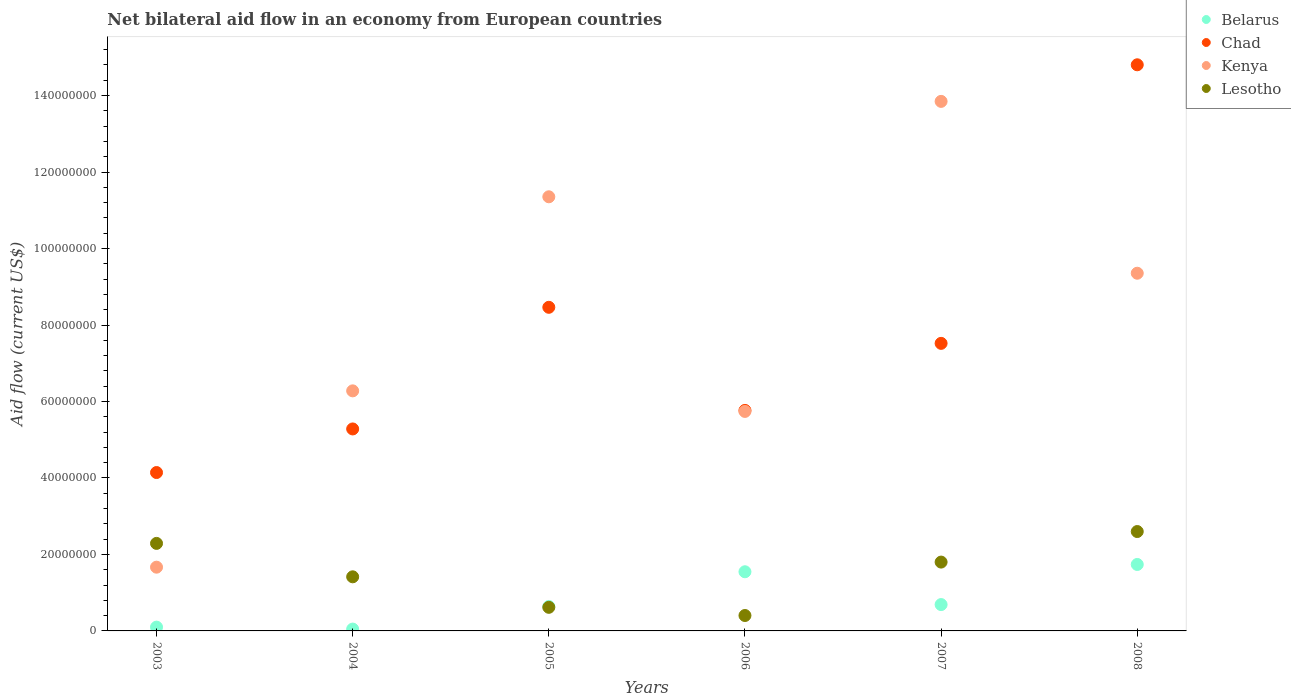What is the net bilateral aid flow in Belarus in 2006?
Provide a short and direct response. 1.55e+07. Across all years, what is the maximum net bilateral aid flow in Chad?
Your response must be concise. 1.48e+08. In which year was the net bilateral aid flow in Kenya maximum?
Provide a short and direct response. 2007. In which year was the net bilateral aid flow in Chad minimum?
Your answer should be very brief. 2003. What is the total net bilateral aid flow in Chad in the graph?
Ensure brevity in your answer.  4.60e+08. What is the difference between the net bilateral aid flow in Chad in 2007 and that in 2008?
Make the answer very short. -7.28e+07. What is the difference between the net bilateral aid flow in Kenya in 2004 and the net bilateral aid flow in Lesotho in 2008?
Keep it short and to the point. 3.68e+07. What is the average net bilateral aid flow in Chad per year?
Your answer should be compact. 7.66e+07. In the year 2005, what is the difference between the net bilateral aid flow in Lesotho and net bilateral aid flow in Belarus?
Your response must be concise. -2.20e+05. In how many years, is the net bilateral aid flow in Belarus greater than 124000000 US$?
Offer a terse response. 0. What is the ratio of the net bilateral aid flow in Kenya in 2005 to that in 2007?
Your answer should be compact. 0.82. Is the difference between the net bilateral aid flow in Lesotho in 2005 and 2007 greater than the difference between the net bilateral aid flow in Belarus in 2005 and 2007?
Offer a terse response. No. What is the difference between the highest and the second highest net bilateral aid flow in Chad?
Offer a very short reply. 6.34e+07. What is the difference between the highest and the lowest net bilateral aid flow in Kenya?
Your answer should be compact. 1.22e+08. Is it the case that in every year, the sum of the net bilateral aid flow in Lesotho and net bilateral aid flow in Belarus  is greater than the sum of net bilateral aid flow in Chad and net bilateral aid flow in Kenya?
Your response must be concise. No. Is it the case that in every year, the sum of the net bilateral aid flow in Lesotho and net bilateral aid flow in Belarus  is greater than the net bilateral aid flow in Kenya?
Keep it short and to the point. No. Does the net bilateral aid flow in Lesotho monotonically increase over the years?
Your answer should be very brief. No. Is the net bilateral aid flow in Chad strictly greater than the net bilateral aid flow in Lesotho over the years?
Provide a short and direct response. Yes. Does the graph contain any zero values?
Keep it short and to the point. No. Where does the legend appear in the graph?
Your answer should be very brief. Top right. What is the title of the graph?
Offer a very short reply. Net bilateral aid flow in an economy from European countries. Does "Seychelles" appear as one of the legend labels in the graph?
Your answer should be very brief. No. What is the Aid flow (current US$) of Belarus in 2003?
Ensure brevity in your answer.  9.90e+05. What is the Aid flow (current US$) in Chad in 2003?
Ensure brevity in your answer.  4.14e+07. What is the Aid flow (current US$) in Kenya in 2003?
Your response must be concise. 1.67e+07. What is the Aid flow (current US$) of Lesotho in 2003?
Ensure brevity in your answer.  2.29e+07. What is the Aid flow (current US$) of Belarus in 2004?
Your answer should be very brief. 4.80e+05. What is the Aid flow (current US$) of Chad in 2004?
Give a very brief answer. 5.28e+07. What is the Aid flow (current US$) of Kenya in 2004?
Offer a terse response. 6.28e+07. What is the Aid flow (current US$) in Lesotho in 2004?
Ensure brevity in your answer.  1.42e+07. What is the Aid flow (current US$) in Belarus in 2005?
Provide a succinct answer. 6.39e+06. What is the Aid flow (current US$) of Chad in 2005?
Offer a very short reply. 8.46e+07. What is the Aid flow (current US$) in Kenya in 2005?
Provide a succinct answer. 1.14e+08. What is the Aid flow (current US$) in Lesotho in 2005?
Offer a terse response. 6.17e+06. What is the Aid flow (current US$) in Belarus in 2006?
Provide a short and direct response. 1.55e+07. What is the Aid flow (current US$) in Chad in 2006?
Make the answer very short. 5.77e+07. What is the Aid flow (current US$) of Kenya in 2006?
Offer a terse response. 5.74e+07. What is the Aid flow (current US$) in Lesotho in 2006?
Your response must be concise. 4.03e+06. What is the Aid flow (current US$) of Belarus in 2007?
Provide a short and direct response. 6.89e+06. What is the Aid flow (current US$) in Chad in 2007?
Provide a succinct answer. 7.52e+07. What is the Aid flow (current US$) of Kenya in 2007?
Offer a terse response. 1.38e+08. What is the Aid flow (current US$) in Lesotho in 2007?
Your response must be concise. 1.80e+07. What is the Aid flow (current US$) in Belarus in 2008?
Give a very brief answer. 1.74e+07. What is the Aid flow (current US$) of Chad in 2008?
Provide a succinct answer. 1.48e+08. What is the Aid flow (current US$) in Kenya in 2008?
Ensure brevity in your answer.  9.35e+07. What is the Aid flow (current US$) in Lesotho in 2008?
Your answer should be very brief. 2.60e+07. Across all years, what is the maximum Aid flow (current US$) of Belarus?
Ensure brevity in your answer.  1.74e+07. Across all years, what is the maximum Aid flow (current US$) in Chad?
Make the answer very short. 1.48e+08. Across all years, what is the maximum Aid flow (current US$) of Kenya?
Your answer should be compact. 1.38e+08. Across all years, what is the maximum Aid flow (current US$) of Lesotho?
Ensure brevity in your answer.  2.60e+07. Across all years, what is the minimum Aid flow (current US$) of Belarus?
Make the answer very short. 4.80e+05. Across all years, what is the minimum Aid flow (current US$) of Chad?
Offer a very short reply. 4.14e+07. Across all years, what is the minimum Aid flow (current US$) in Kenya?
Provide a short and direct response. 1.67e+07. Across all years, what is the minimum Aid flow (current US$) of Lesotho?
Ensure brevity in your answer.  4.03e+06. What is the total Aid flow (current US$) of Belarus in the graph?
Your answer should be very brief. 4.76e+07. What is the total Aid flow (current US$) in Chad in the graph?
Your answer should be compact. 4.60e+08. What is the total Aid flow (current US$) of Kenya in the graph?
Keep it short and to the point. 4.82e+08. What is the total Aid flow (current US$) of Lesotho in the graph?
Provide a succinct answer. 9.12e+07. What is the difference between the Aid flow (current US$) in Belarus in 2003 and that in 2004?
Your answer should be very brief. 5.10e+05. What is the difference between the Aid flow (current US$) of Chad in 2003 and that in 2004?
Ensure brevity in your answer.  -1.14e+07. What is the difference between the Aid flow (current US$) in Kenya in 2003 and that in 2004?
Offer a very short reply. -4.61e+07. What is the difference between the Aid flow (current US$) of Lesotho in 2003 and that in 2004?
Keep it short and to the point. 8.74e+06. What is the difference between the Aid flow (current US$) in Belarus in 2003 and that in 2005?
Provide a succinct answer. -5.40e+06. What is the difference between the Aid flow (current US$) in Chad in 2003 and that in 2005?
Provide a succinct answer. -4.32e+07. What is the difference between the Aid flow (current US$) of Kenya in 2003 and that in 2005?
Make the answer very short. -9.69e+07. What is the difference between the Aid flow (current US$) in Lesotho in 2003 and that in 2005?
Ensure brevity in your answer.  1.67e+07. What is the difference between the Aid flow (current US$) of Belarus in 2003 and that in 2006?
Provide a short and direct response. -1.45e+07. What is the difference between the Aid flow (current US$) of Chad in 2003 and that in 2006?
Your response must be concise. -1.62e+07. What is the difference between the Aid flow (current US$) in Kenya in 2003 and that in 2006?
Offer a very short reply. -4.07e+07. What is the difference between the Aid flow (current US$) in Lesotho in 2003 and that in 2006?
Ensure brevity in your answer.  1.89e+07. What is the difference between the Aid flow (current US$) of Belarus in 2003 and that in 2007?
Your answer should be compact. -5.90e+06. What is the difference between the Aid flow (current US$) of Chad in 2003 and that in 2007?
Offer a terse response. -3.38e+07. What is the difference between the Aid flow (current US$) of Kenya in 2003 and that in 2007?
Provide a succinct answer. -1.22e+08. What is the difference between the Aid flow (current US$) of Lesotho in 2003 and that in 2007?
Your answer should be compact. 4.89e+06. What is the difference between the Aid flow (current US$) in Belarus in 2003 and that in 2008?
Ensure brevity in your answer.  -1.64e+07. What is the difference between the Aid flow (current US$) of Chad in 2003 and that in 2008?
Offer a very short reply. -1.07e+08. What is the difference between the Aid flow (current US$) in Kenya in 2003 and that in 2008?
Provide a succinct answer. -7.69e+07. What is the difference between the Aid flow (current US$) in Lesotho in 2003 and that in 2008?
Provide a succinct answer. -3.10e+06. What is the difference between the Aid flow (current US$) of Belarus in 2004 and that in 2005?
Your response must be concise. -5.91e+06. What is the difference between the Aid flow (current US$) in Chad in 2004 and that in 2005?
Your response must be concise. -3.18e+07. What is the difference between the Aid flow (current US$) in Kenya in 2004 and that in 2005?
Offer a terse response. -5.08e+07. What is the difference between the Aid flow (current US$) in Lesotho in 2004 and that in 2005?
Your response must be concise. 7.98e+06. What is the difference between the Aid flow (current US$) of Belarus in 2004 and that in 2006?
Your answer should be compact. -1.50e+07. What is the difference between the Aid flow (current US$) of Chad in 2004 and that in 2006?
Provide a short and direct response. -4.85e+06. What is the difference between the Aid flow (current US$) in Kenya in 2004 and that in 2006?
Give a very brief answer. 5.38e+06. What is the difference between the Aid flow (current US$) of Lesotho in 2004 and that in 2006?
Make the answer very short. 1.01e+07. What is the difference between the Aid flow (current US$) in Belarus in 2004 and that in 2007?
Make the answer very short. -6.41e+06. What is the difference between the Aid flow (current US$) in Chad in 2004 and that in 2007?
Provide a succinct answer. -2.24e+07. What is the difference between the Aid flow (current US$) of Kenya in 2004 and that in 2007?
Offer a terse response. -7.57e+07. What is the difference between the Aid flow (current US$) in Lesotho in 2004 and that in 2007?
Give a very brief answer. -3.85e+06. What is the difference between the Aid flow (current US$) of Belarus in 2004 and that in 2008?
Provide a short and direct response. -1.69e+07. What is the difference between the Aid flow (current US$) in Chad in 2004 and that in 2008?
Your answer should be compact. -9.52e+07. What is the difference between the Aid flow (current US$) in Kenya in 2004 and that in 2008?
Keep it short and to the point. -3.08e+07. What is the difference between the Aid flow (current US$) in Lesotho in 2004 and that in 2008?
Provide a succinct answer. -1.18e+07. What is the difference between the Aid flow (current US$) of Belarus in 2005 and that in 2006?
Offer a terse response. -9.08e+06. What is the difference between the Aid flow (current US$) in Chad in 2005 and that in 2006?
Provide a short and direct response. 2.70e+07. What is the difference between the Aid flow (current US$) of Kenya in 2005 and that in 2006?
Provide a succinct answer. 5.61e+07. What is the difference between the Aid flow (current US$) of Lesotho in 2005 and that in 2006?
Provide a short and direct response. 2.14e+06. What is the difference between the Aid flow (current US$) in Belarus in 2005 and that in 2007?
Your response must be concise. -5.00e+05. What is the difference between the Aid flow (current US$) in Chad in 2005 and that in 2007?
Keep it short and to the point. 9.43e+06. What is the difference between the Aid flow (current US$) of Kenya in 2005 and that in 2007?
Your answer should be compact. -2.50e+07. What is the difference between the Aid flow (current US$) in Lesotho in 2005 and that in 2007?
Offer a terse response. -1.18e+07. What is the difference between the Aid flow (current US$) in Belarus in 2005 and that in 2008?
Provide a short and direct response. -1.10e+07. What is the difference between the Aid flow (current US$) in Chad in 2005 and that in 2008?
Make the answer very short. -6.34e+07. What is the difference between the Aid flow (current US$) of Kenya in 2005 and that in 2008?
Offer a very short reply. 2.00e+07. What is the difference between the Aid flow (current US$) of Lesotho in 2005 and that in 2008?
Ensure brevity in your answer.  -1.98e+07. What is the difference between the Aid flow (current US$) of Belarus in 2006 and that in 2007?
Your response must be concise. 8.58e+06. What is the difference between the Aid flow (current US$) in Chad in 2006 and that in 2007?
Ensure brevity in your answer.  -1.75e+07. What is the difference between the Aid flow (current US$) in Kenya in 2006 and that in 2007?
Provide a succinct answer. -8.11e+07. What is the difference between the Aid flow (current US$) in Lesotho in 2006 and that in 2007?
Provide a short and direct response. -1.40e+07. What is the difference between the Aid flow (current US$) in Belarus in 2006 and that in 2008?
Offer a terse response. -1.91e+06. What is the difference between the Aid flow (current US$) of Chad in 2006 and that in 2008?
Your answer should be compact. -9.04e+07. What is the difference between the Aid flow (current US$) in Kenya in 2006 and that in 2008?
Make the answer very short. -3.61e+07. What is the difference between the Aid flow (current US$) of Lesotho in 2006 and that in 2008?
Make the answer very short. -2.20e+07. What is the difference between the Aid flow (current US$) in Belarus in 2007 and that in 2008?
Provide a succinct answer. -1.05e+07. What is the difference between the Aid flow (current US$) of Chad in 2007 and that in 2008?
Provide a succinct answer. -7.28e+07. What is the difference between the Aid flow (current US$) of Kenya in 2007 and that in 2008?
Make the answer very short. 4.49e+07. What is the difference between the Aid flow (current US$) in Lesotho in 2007 and that in 2008?
Your answer should be very brief. -7.99e+06. What is the difference between the Aid flow (current US$) of Belarus in 2003 and the Aid flow (current US$) of Chad in 2004?
Keep it short and to the point. -5.18e+07. What is the difference between the Aid flow (current US$) in Belarus in 2003 and the Aid flow (current US$) in Kenya in 2004?
Give a very brief answer. -6.18e+07. What is the difference between the Aid flow (current US$) of Belarus in 2003 and the Aid flow (current US$) of Lesotho in 2004?
Ensure brevity in your answer.  -1.32e+07. What is the difference between the Aid flow (current US$) of Chad in 2003 and the Aid flow (current US$) of Kenya in 2004?
Offer a terse response. -2.14e+07. What is the difference between the Aid flow (current US$) of Chad in 2003 and the Aid flow (current US$) of Lesotho in 2004?
Your answer should be compact. 2.73e+07. What is the difference between the Aid flow (current US$) of Kenya in 2003 and the Aid flow (current US$) of Lesotho in 2004?
Provide a short and direct response. 2.52e+06. What is the difference between the Aid flow (current US$) of Belarus in 2003 and the Aid flow (current US$) of Chad in 2005?
Offer a terse response. -8.36e+07. What is the difference between the Aid flow (current US$) in Belarus in 2003 and the Aid flow (current US$) in Kenya in 2005?
Your answer should be compact. -1.13e+08. What is the difference between the Aid flow (current US$) in Belarus in 2003 and the Aid flow (current US$) in Lesotho in 2005?
Offer a terse response. -5.18e+06. What is the difference between the Aid flow (current US$) of Chad in 2003 and the Aid flow (current US$) of Kenya in 2005?
Keep it short and to the point. -7.21e+07. What is the difference between the Aid flow (current US$) in Chad in 2003 and the Aid flow (current US$) in Lesotho in 2005?
Your answer should be compact. 3.52e+07. What is the difference between the Aid flow (current US$) of Kenya in 2003 and the Aid flow (current US$) of Lesotho in 2005?
Offer a terse response. 1.05e+07. What is the difference between the Aid flow (current US$) in Belarus in 2003 and the Aid flow (current US$) in Chad in 2006?
Keep it short and to the point. -5.67e+07. What is the difference between the Aid flow (current US$) of Belarus in 2003 and the Aid flow (current US$) of Kenya in 2006?
Give a very brief answer. -5.64e+07. What is the difference between the Aid flow (current US$) of Belarus in 2003 and the Aid flow (current US$) of Lesotho in 2006?
Make the answer very short. -3.04e+06. What is the difference between the Aid flow (current US$) of Chad in 2003 and the Aid flow (current US$) of Kenya in 2006?
Offer a very short reply. -1.60e+07. What is the difference between the Aid flow (current US$) in Chad in 2003 and the Aid flow (current US$) in Lesotho in 2006?
Give a very brief answer. 3.74e+07. What is the difference between the Aid flow (current US$) of Kenya in 2003 and the Aid flow (current US$) of Lesotho in 2006?
Keep it short and to the point. 1.26e+07. What is the difference between the Aid flow (current US$) of Belarus in 2003 and the Aid flow (current US$) of Chad in 2007?
Keep it short and to the point. -7.42e+07. What is the difference between the Aid flow (current US$) of Belarus in 2003 and the Aid flow (current US$) of Kenya in 2007?
Your response must be concise. -1.37e+08. What is the difference between the Aid flow (current US$) in Belarus in 2003 and the Aid flow (current US$) in Lesotho in 2007?
Your answer should be very brief. -1.70e+07. What is the difference between the Aid flow (current US$) of Chad in 2003 and the Aid flow (current US$) of Kenya in 2007?
Offer a terse response. -9.71e+07. What is the difference between the Aid flow (current US$) of Chad in 2003 and the Aid flow (current US$) of Lesotho in 2007?
Keep it short and to the point. 2.34e+07. What is the difference between the Aid flow (current US$) of Kenya in 2003 and the Aid flow (current US$) of Lesotho in 2007?
Make the answer very short. -1.33e+06. What is the difference between the Aid flow (current US$) in Belarus in 2003 and the Aid flow (current US$) in Chad in 2008?
Ensure brevity in your answer.  -1.47e+08. What is the difference between the Aid flow (current US$) of Belarus in 2003 and the Aid flow (current US$) of Kenya in 2008?
Provide a short and direct response. -9.26e+07. What is the difference between the Aid flow (current US$) in Belarus in 2003 and the Aid flow (current US$) in Lesotho in 2008?
Offer a very short reply. -2.50e+07. What is the difference between the Aid flow (current US$) in Chad in 2003 and the Aid flow (current US$) in Kenya in 2008?
Ensure brevity in your answer.  -5.21e+07. What is the difference between the Aid flow (current US$) of Chad in 2003 and the Aid flow (current US$) of Lesotho in 2008?
Offer a very short reply. 1.54e+07. What is the difference between the Aid flow (current US$) of Kenya in 2003 and the Aid flow (current US$) of Lesotho in 2008?
Your response must be concise. -9.32e+06. What is the difference between the Aid flow (current US$) of Belarus in 2004 and the Aid flow (current US$) of Chad in 2005?
Provide a short and direct response. -8.42e+07. What is the difference between the Aid flow (current US$) in Belarus in 2004 and the Aid flow (current US$) in Kenya in 2005?
Offer a very short reply. -1.13e+08. What is the difference between the Aid flow (current US$) in Belarus in 2004 and the Aid flow (current US$) in Lesotho in 2005?
Provide a short and direct response. -5.69e+06. What is the difference between the Aid flow (current US$) of Chad in 2004 and the Aid flow (current US$) of Kenya in 2005?
Keep it short and to the point. -6.07e+07. What is the difference between the Aid flow (current US$) in Chad in 2004 and the Aid flow (current US$) in Lesotho in 2005?
Give a very brief answer. 4.66e+07. What is the difference between the Aid flow (current US$) of Kenya in 2004 and the Aid flow (current US$) of Lesotho in 2005?
Give a very brief answer. 5.66e+07. What is the difference between the Aid flow (current US$) in Belarus in 2004 and the Aid flow (current US$) in Chad in 2006?
Make the answer very short. -5.72e+07. What is the difference between the Aid flow (current US$) of Belarus in 2004 and the Aid flow (current US$) of Kenya in 2006?
Provide a short and direct response. -5.69e+07. What is the difference between the Aid flow (current US$) of Belarus in 2004 and the Aid flow (current US$) of Lesotho in 2006?
Ensure brevity in your answer.  -3.55e+06. What is the difference between the Aid flow (current US$) in Chad in 2004 and the Aid flow (current US$) in Kenya in 2006?
Provide a succinct answer. -4.58e+06. What is the difference between the Aid flow (current US$) in Chad in 2004 and the Aid flow (current US$) in Lesotho in 2006?
Your response must be concise. 4.88e+07. What is the difference between the Aid flow (current US$) of Kenya in 2004 and the Aid flow (current US$) of Lesotho in 2006?
Offer a very short reply. 5.88e+07. What is the difference between the Aid flow (current US$) in Belarus in 2004 and the Aid flow (current US$) in Chad in 2007?
Provide a short and direct response. -7.47e+07. What is the difference between the Aid flow (current US$) in Belarus in 2004 and the Aid flow (current US$) in Kenya in 2007?
Your response must be concise. -1.38e+08. What is the difference between the Aid flow (current US$) of Belarus in 2004 and the Aid flow (current US$) of Lesotho in 2007?
Make the answer very short. -1.75e+07. What is the difference between the Aid flow (current US$) of Chad in 2004 and the Aid flow (current US$) of Kenya in 2007?
Offer a terse response. -8.57e+07. What is the difference between the Aid flow (current US$) in Chad in 2004 and the Aid flow (current US$) in Lesotho in 2007?
Your answer should be compact. 3.48e+07. What is the difference between the Aid flow (current US$) of Kenya in 2004 and the Aid flow (current US$) of Lesotho in 2007?
Provide a short and direct response. 4.48e+07. What is the difference between the Aid flow (current US$) of Belarus in 2004 and the Aid flow (current US$) of Chad in 2008?
Your response must be concise. -1.48e+08. What is the difference between the Aid flow (current US$) in Belarus in 2004 and the Aid flow (current US$) in Kenya in 2008?
Provide a short and direct response. -9.31e+07. What is the difference between the Aid flow (current US$) in Belarus in 2004 and the Aid flow (current US$) in Lesotho in 2008?
Provide a succinct answer. -2.55e+07. What is the difference between the Aid flow (current US$) of Chad in 2004 and the Aid flow (current US$) of Kenya in 2008?
Your response must be concise. -4.07e+07. What is the difference between the Aid flow (current US$) of Chad in 2004 and the Aid flow (current US$) of Lesotho in 2008?
Provide a short and direct response. 2.68e+07. What is the difference between the Aid flow (current US$) in Kenya in 2004 and the Aid flow (current US$) in Lesotho in 2008?
Your answer should be very brief. 3.68e+07. What is the difference between the Aid flow (current US$) in Belarus in 2005 and the Aid flow (current US$) in Chad in 2006?
Make the answer very short. -5.13e+07. What is the difference between the Aid flow (current US$) of Belarus in 2005 and the Aid flow (current US$) of Kenya in 2006?
Your answer should be very brief. -5.10e+07. What is the difference between the Aid flow (current US$) of Belarus in 2005 and the Aid flow (current US$) of Lesotho in 2006?
Offer a terse response. 2.36e+06. What is the difference between the Aid flow (current US$) of Chad in 2005 and the Aid flow (current US$) of Kenya in 2006?
Give a very brief answer. 2.72e+07. What is the difference between the Aid flow (current US$) of Chad in 2005 and the Aid flow (current US$) of Lesotho in 2006?
Your answer should be very brief. 8.06e+07. What is the difference between the Aid flow (current US$) in Kenya in 2005 and the Aid flow (current US$) in Lesotho in 2006?
Provide a succinct answer. 1.10e+08. What is the difference between the Aid flow (current US$) of Belarus in 2005 and the Aid flow (current US$) of Chad in 2007?
Offer a terse response. -6.88e+07. What is the difference between the Aid flow (current US$) in Belarus in 2005 and the Aid flow (current US$) in Kenya in 2007?
Offer a terse response. -1.32e+08. What is the difference between the Aid flow (current US$) in Belarus in 2005 and the Aid flow (current US$) in Lesotho in 2007?
Give a very brief answer. -1.16e+07. What is the difference between the Aid flow (current US$) in Chad in 2005 and the Aid flow (current US$) in Kenya in 2007?
Provide a short and direct response. -5.38e+07. What is the difference between the Aid flow (current US$) of Chad in 2005 and the Aid flow (current US$) of Lesotho in 2007?
Provide a short and direct response. 6.66e+07. What is the difference between the Aid flow (current US$) of Kenya in 2005 and the Aid flow (current US$) of Lesotho in 2007?
Give a very brief answer. 9.55e+07. What is the difference between the Aid flow (current US$) in Belarus in 2005 and the Aid flow (current US$) in Chad in 2008?
Give a very brief answer. -1.42e+08. What is the difference between the Aid flow (current US$) of Belarus in 2005 and the Aid flow (current US$) of Kenya in 2008?
Offer a terse response. -8.72e+07. What is the difference between the Aid flow (current US$) of Belarus in 2005 and the Aid flow (current US$) of Lesotho in 2008?
Give a very brief answer. -1.96e+07. What is the difference between the Aid flow (current US$) of Chad in 2005 and the Aid flow (current US$) of Kenya in 2008?
Offer a terse response. -8.91e+06. What is the difference between the Aid flow (current US$) of Chad in 2005 and the Aid flow (current US$) of Lesotho in 2008?
Your answer should be very brief. 5.86e+07. What is the difference between the Aid flow (current US$) in Kenya in 2005 and the Aid flow (current US$) in Lesotho in 2008?
Keep it short and to the point. 8.75e+07. What is the difference between the Aid flow (current US$) in Belarus in 2006 and the Aid flow (current US$) in Chad in 2007?
Offer a terse response. -5.97e+07. What is the difference between the Aid flow (current US$) of Belarus in 2006 and the Aid flow (current US$) of Kenya in 2007?
Offer a terse response. -1.23e+08. What is the difference between the Aid flow (current US$) of Belarus in 2006 and the Aid flow (current US$) of Lesotho in 2007?
Make the answer very short. -2.53e+06. What is the difference between the Aid flow (current US$) of Chad in 2006 and the Aid flow (current US$) of Kenya in 2007?
Provide a short and direct response. -8.08e+07. What is the difference between the Aid flow (current US$) in Chad in 2006 and the Aid flow (current US$) in Lesotho in 2007?
Your answer should be compact. 3.97e+07. What is the difference between the Aid flow (current US$) of Kenya in 2006 and the Aid flow (current US$) of Lesotho in 2007?
Provide a succinct answer. 3.94e+07. What is the difference between the Aid flow (current US$) in Belarus in 2006 and the Aid flow (current US$) in Chad in 2008?
Offer a very short reply. -1.33e+08. What is the difference between the Aid flow (current US$) in Belarus in 2006 and the Aid flow (current US$) in Kenya in 2008?
Your response must be concise. -7.81e+07. What is the difference between the Aid flow (current US$) in Belarus in 2006 and the Aid flow (current US$) in Lesotho in 2008?
Provide a short and direct response. -1.05e+07. What is the difference between the Aid flow (current US$) of Chad in 2006 and the Aid flow (current US$) of Kenya in 2008?
Offer a very short reply. -3.59e+07. What is the difference between the Aid flow (current US$) of Chad in 2006 and the Aid flow (current US$) of Lesotho in 2008?
Offer a terse response. 3.17e+07. What is the difference between the Aid flow (current US$) in Kenya in 2006 and the Aid flow (current US$) in Lesotho in 2008?
Your answer should be very brief. 3.14e+07. What is the difference between the Aid flow (current US$) in Belarus in 2007 and the Aid flow (current US$) in Chad in 2008?
Your response must be concise. -1.41e+08. What is the difference between the Aid flow (current US$) in Belarus in 2007 and the Aid flow (current US$) in Kenya in 2008?
Your response must be concise. -8.66e+07. What is the difference between the Aid flow (current US$) of Belarus in 2007 and the Aid flow (current US$) of Lesotho in 2008?
Keep it short and to the point. -1.91e+07. What is the difference between the Aid flow (current US$) in Chad in 2007 and the Aid flow (current US$) in Kenya in 2008?
Ensure brevity in your answer.  -1.83e+07. What is the difference between the Aid flow (current US$) in Chad in 2007 and the Aid flow (current US$) in Lesotho in 2008?
Offer a very short reply. 4.92e+07. What is the difference between the Aid flow (current US$) of Kenya in 2007 and the Aid flow (current US$) of Lesotho in 2008?
Your answer should be very brief. 1.12e+08. What is the average Aid flow (current US$) of Belarus per year?
Keep it short and to the point. 7.93e+06. What is the average Aid flow (current US$) in Chad per year?
Make the answer very short. 7.66e+07. What is the average Aid flow (current US$) in Kenya per year?
Provide a succinct answer. 8.04e+07. What is the average Aid flow (current US$) in Lesotho per year?
Your answer should be compact. 1.52e+07. In the year 2003, what is the difference between the Aid flow (current US$) in Belarus and Aid flow (current US$) in Chad?
Provide a succinct answer. -4.04e+07. In the year 2003, what is the difference between the Aid flow (current US$) in Belarus and Aid flow (current US$) in Kenya?
Offer a very short reply. -1.57e+07. In the year 2003, what is the difference between the Aid flow (current US$) in Belarus and Aid flow (current US$) in Lesotho?
Your response must be concise. -2.19e+07. In the year 2003, what is the difference between the Aid flow (current US$) in Chad and Aid flow (current US$) in Kenya?
Your answer should be very brief. 2.48e+07. In the year 2003, what is the difference between the Aid flow (current US$) of Chad and Aid flow (current US$) of Lesotho?
Your answer should be very brief. 1.85e+07. In the year 2003, what is the difference between the Aid flow (current US$) of Kenya and Aid flow (current US$) of Lesotho?
Give a very brief answer. -6.22e+06. In the year 2004, what is the difference between the Aid flow (current US$) in Belarus and Aid flow (current US$) in Chad?
Your answer should be compact. -5.23e+07. In the year 2004, what is the difference between the Aid flow (current US$) of Belarus and Aid flow (current US$) of Kenya?
Offer a terse response. -6.23e+07. In the year 2004, what is the difference between the Aid flow (current US$) of Belarus and Aid flow (current US$) of Lesotho?
Ensure brevity in your answer.  -1.37e+07. In the year 2004, what is the difference between the Aid flow (current US$) in Chad and Aid flow (current US$) in Kenya?
Make the answer very short. -9.96e+06. In the year 2004, what is the difference between the Aid flow (current US$) in Chad and Aid flow (current US$) in Lesotho?
Provide a short and direct response. 3.87e+07. In the year 2004, what is the difference between the Aid flow (current US$) of Kenya and Aid flow (current US$) of Lesotho?
Provide a short and direct response. 4.86e+07. In the year 2005, what is the difference between the Aid flow (current US$) in Belarus and Aid flow (current US$) in Chad?
Offer a terse response. -7.82e+07. In the year 2005, what is the difference between the Aid flow (current US$) of Belarus and Aid flow (current US$) of Kenya?
Provide a short and direct response. -1.07e+08. In the year 2005, what is the difference between the Aid flow (current US$) in Chad and Aid flow (current US$) in Kenya?
Your answer should be very brief. -2.89e+07. In the year 2005, what is the difference between the Aid flow (current US$) in Chad and Aid flow (current US$) in Lesotho?
Offer a very short reply. 7.85e+07. In the year 2005, what is the difference between the Aid flow (current US$) of Kenya and Aid flow (current US$) of Lesotho?
Keep it short and to the point. 1.07e+08. In the year 2006, what is the difference between the Aid flow (current US$) of Belarus and Aid flow (current US$) of Chad?
Make the answer very short. -4.22e+07. In the year 2006, what is the difference between the Aid flow (current US$) in Belarus and Aid flow (current US$) in Kenya?
Give a very brief answer. -4.19e+07. In the year 2006, what is the difference between the Aid flow (current US$) in Belarus and Aid flow (current US$) in Lesotho?
Keep it short and to the point. 1.14e+07. In the year 2006, what is the difference between the Aid flow (current US$) of Chad and Aid flow (current US$) of Lesotho?
Your response must be concise. 5.36e+07. In the year 2006, what is the difference between the Aid flow (current US$) in Kenya and Aid flow (current US$) in Lesotho?
Provide a succinct answer. 5.34e+07. In the year 2007, what is the difference between the Aid flow (current US$) in Belarus and Aid flow (current US$) in Chad?
Make the answer very short. -6.83e+07. In the year 2007, what is the difference between the Aid flow (current US$) in Belarus and Aid flow (current US$) in Kenya?
Make the answer very short. -1.32e+08. In the year 2007, what is the difference between the Aid flow (current US$) in Belarus and Aid flow (current US$) in Lesotho?
Offer a very short reply. -1.11e+07. In the year 2007, what is the difference between the Aid flow (current US$) of Chad and Aid flow (current US$) of Kenya?
Your answer should be compact. -6.33e+07. In the year 2007, what is the difference between the Aid flow (current US$) in Chad and Aid flow (current US$) in Lesotho?
Offer a terse response. 5.72e+07. In the year 2007, what is the difference between the Aid flow (current US$) of Kenya and Aid flow (current US$) of Lesotho?
Provide a short and direct response. 1.20e+08. In the year 2008, what is the difference between the Aid flow (current US$) in Belarus and Aid flow (current US$) in Chad?
Your response must be concise. -1.31e+08. In the year 2008, what is the difference between the Aid flow (current US$) in Belarus and Aid flow (current US$) in Kenya?
Provide a short and direct response. -7.62e+07. In the year 2008, what is the difference between the Aid flow (current US$) of Belarus and Aid flow (current US$) of Lesotho?
Offer a very short reply. -8.61e+06. In the year 2008, what is the difference between the Aid flow (current US$) of Chad and Aid flow (current US$) of Kenya?
Make the answer very short. 5.45e+07. In the year 2008, what is the difference between the Aid flow (current US$) in Chad and Aid flow (current US$) in Lesotho?
Provide a succinct answer. 1.22e+08. In the year 2008, what is the difference between the Aid flow (current US$) in Kenya and Aid flow (current US$) in Lesotho?
Keep it short and to the point. 6.76e+07. What is the ratio of the Aid flow (current US$) of Belarus in 2003 to that in 2004?
Ensure brevity in your answer.  2.06. What is the ratio of the Aid flow (current US$) of Chad in 2003 to that in 2004?
Your answer should be compact. 0.78. What is the ratio of the Aid flow (current US$) of Kenya in 2003 to that in 2004?
Give a very brief answer. 0.27. What is the ratio of the Aid flow (current US$) in Lesotho in 2003 to that in 2004?
Offer a terse response. 1.62. What is the ratio of the Aid flow (current US$) of Belarus in 2003 to that in 2005?
Provide a succinct answer. 0.15. What is the ratio of the Aid flow (current US$) of Chad in 2003 to that in 2005?
Provide a short and direct response. 0.49. What is the ratio of the Aid flow (current US$) of Kenya in 2003 to that in 2005?
Make the answer very short. 0.15. What is the ratio of the Aid flow (current US$) in Lesotho in 2003 to that in 2005?
Your answer should be compact. 3.71. What is the ratio of the Aid flow (current US$) of Belarus in 2003 to that in 2006?
Your response must be concise. 0.06. What is the ratio of the Aid flow (current US$) in Chad in 2003 to that in 2006?
Offer a very short reply. 0.72. What is the ratio of the Aid flow (current US$) in Kenya in 2003 to that in 2006?
Your answer should be compact. 0.29. What is the ratio of the Aid flow (current US$) of Lesotho in 2003 to that in 2006?
Your answer should be very brief. 5.68. What is the ratio of the Aid flow (current US$) of Belarus in 2003 to that in 2007?
Give a very brief answer. 0.14. What is the ratio of the Aid flow (current US$) of Chad in 2003 to that in 2007?
Provide a short and direct response. 0.55. What is the ratio of the Aid flow (current US$) in Kenya in 2003 to that in 2007?
Your answer should be compact. 0.12. What is the ratio of the Aid flow (current US$) in Lesotho in 2003 to that in 2007?
Provide a succinct answer. 1.27. What is the ratio of the Aid flow (current US$) in Belarus in 2003 to that in 2008?
Provide a succinct answer. 0.06. What is the ratio of the Aid flow (current US$) of Chad in 2003 to that in 2008?
Provide a short and direct response. 0.28. What is the ratio of the Aid flow (current US$) in Kenya in 2003 to that in 2008?
Ensure brevity in your answer.  0.18. What is the ratio of the Aid flow (current US$) of Lesotho in 2003 to that in 2008?
Offer a very short reply. 0.88. What is the ratio of the Aid flow (current US$) of Belarus in 2004 to that in 2005?
Provide a succinct answer. 0.08. What is the ratio of the Aid flow (current US$) of Chad in 2004 to that in 2005?
Your response must be concise. 0.62. What is the ratio of the Aid flow (current US$) of Kenya in 2004 to that in 2005?
Make the answer very short. 0.55. What is the ratio of the Aid flow (current US$) of Lesotho in 2004 to that in 2005?
Provide a succinct answer. 2.29. What is the ratio of the Aid flow (current US$) in Belarus in 2004 to that in 2006?
Make the answer very short. 0.03. What is the ratio of the Aid flow (current US$) of Chad in 2004 to that in 2006?
Your answer should be compact. 0.92. What is the ratio of the Aid flow (current US$) of Kenya in 2004 to that in 2006?
Offer a terse response. 1.09. What is the ratio of the Aid flow (current US$) in Lesotho in 2004 to that in 2006?
Provide a succinct answer. 3.51. What is the ratio of the Aid flow (current US$) of Belarus in 2004 to that in 2007?
Your response must be concise. 0.07. What is the ratio of the Aid flow (current US$) of Chad in 2004 to that in 2007?
Offer a terse response. 0.7. What is the ratio of the Aid flow (current US$) in Kenya in 2004 to that in 2007?
Your answer should be compact. 0.45. What is the ratio of the Aid flow (current US$) of Lesotho in 2004 to that in 2007?
Ensure brevity in your answer.  0.79. What is the ratio of the Aid flow (current US$) of Belarus in 2004 to that in 2008?
Your answer should be very brief. 0.03. What is the ratio of the Aid flow (current US$) of Chad in 2004 to that in 2008?
Provide a short and direct response. 0.36. What is the ratio of the Aid flow (current US$) of Kenya in 2004 to that in 2008?
Your answer should be compact. 0.67. What is the ratio of the Aid flow (current US$) of Lesotho in 2004 to that in 2008?
Give a very brief answer. 0.54. What is the ratio of the Aid flow (current US$) in Belarus in 2005 to that in 2006?
Give a very brief answer. 0.41. What is the ratio of the Aid flow (current US$) in Chad in 2005 to that in 2006?
Provide a short and direct response. 1.47. What is the ratio of the Aid flow (current US$) of Kenya in 2005 to that in 2006?
Provide a succinct answer. 1.98. What is the ratio of the Aid flow (current US$) of Lesotho in 2005 to that in 2006?
Offer a terse response. 1.53. What is the ratio of the Aid flow (current US$) of Belarus in 2005 to that in 2007?
Give a very brief answer. 0.93. What is the ratio of the Aid flow (current US$) in Chad in 2005 to that in 2007?
Offer a very short reply. 1.13. What is the ratio of the Aid flow (current US$) of Kenya in 2005 to that in 2007?
Provide a succinct answer. 0.82. What is the ratio of the Aid flow (current US$) of Lesotho in 2005 to that in 2007?
Keep it short and to the point. 0.34. What is the ratio of the Aid flow (current US$) of Belarus in 2005 to that in 2008?
Your answer should be very brief. 0.37. What is the ratio of the Aid flow (current US$) of Chad in 2005 to that in 2008?
Your response must be concise. 0.57. What is the ratio of the Aid flow (current US$) in Kenya in 2005 to that in 2008?
Make the answer very short. 1.21. What is the ratio of the Aid flow (current US$) of Lesotho in 2005 to that in 2008?
Ensure brevity in your answer.  0.24. What is the ratio of the Aid flow (current US$) in Belarus in 2006 to that in 2007?
Offer a terse response. 2.25. What is the ratio of the Aid flow (current US$) of Chad in 2006 to that in 2007?
Provide a short and direct response. 0.77. What is the ratio of the Aid flow (current US$) of Kenya in 2006 to that in 2007?
Your answer should be compact. 0.41. What is the ratio of the Aid flow (current US$) of Lesotho in 2006 to that in 2007?
Provide a short and direct response. 0.22. What is the ratio of the Aid flow (current US$) of Belarus in 2006 to that in 2008?
Make the answer very short. 0.89. What is the ratio of the Aid flow (current US$) of Chad in 2006 to that in 2008?
Your response must be concise. 0.39. What is the ratio of the Aid flow (current US$) in Kenya in 2006 to that in 2008?
Give a very brief answer. 0.61. What is the ratio of the Aid flow (current US$) in Lesotho in 2006 to that in 2008?
Ensure brevity in your answer.  0.16. What is the ratio of the Aid flow (current US$) in Belarus in 2007 to that in 2008?
Your response must be concise. 0.4. What is the ratio of the Aid flow (current US$) of Chad in 2007 to that in 2008?
Make the answer very short. 0.51. What is the ratio of the Aid flow (current US$) in Kenya in 2007 to that in 2008?
Your answer should be very brief. 1.48. What is the ratio of the Aid flow (current US$) in Lesotho in 2007 to that in 2008?
Provide a short and direct response. 0.69. What is the difference between the highest and the second highest Aid flow (current US$) in Belarus?
Give a very brief answer. 1.91e+06. What is the difference between the highest and the second highest Aid flow (current US$) of Chad?
Ensure brevity in your answer.  6.34e+07. What is the difference between the highest and the second highest Aid flow (current US$) in Kenya?
Make the answer very short. 2.50e+07. What is the difference between the highest and the second highest Aid flow (current US$) in Lesotho?
Provide a short and direct response. 3.10e+06. What is the difference between the highest and the lowest Aid flow (current US$) of Belarus?
Offer a very short reply. 1.69e+07. What is the difference between the highest and the lowest Aid flow (current US$) of Chad?
Offer a terse response. 1.07e+08. What is the difference between the highest and the lowest Aid flow (current US$) in Kenya?
Offer a terse response. 1.22e+08. What is the difference between the highest and the lowest Aid flow (current US$) in Lesotho?
Provide a short and direct response. 2.20e+07. 